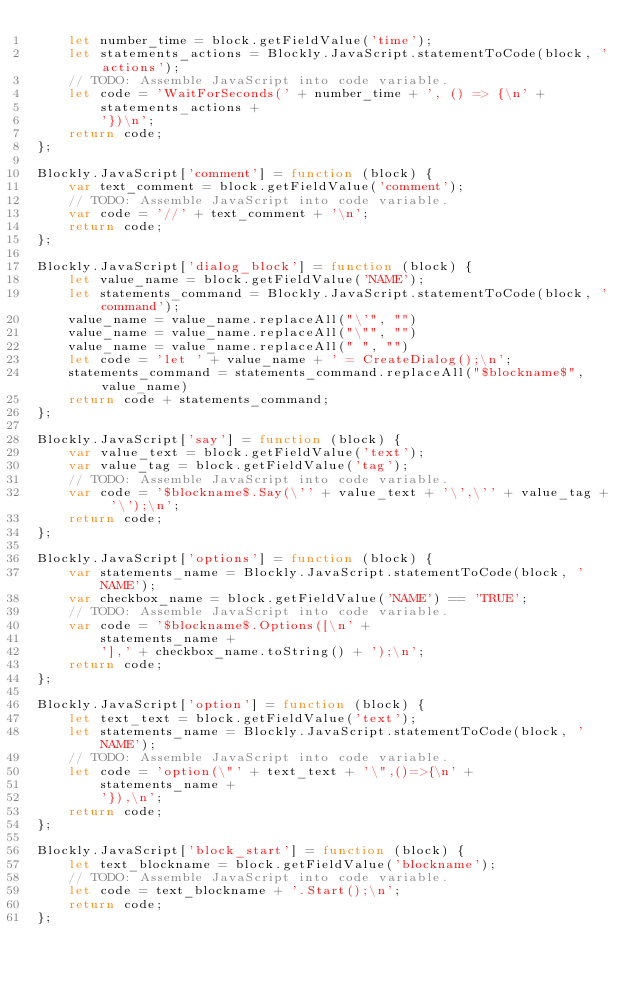Convert code to text. <code><loc_0><loc_0><loc_500><loc_500><_JavaScript_>    let number_time = block.getFieldValue('time');
    let statements_actions = Blockly.JavaScript.statementToCode(block, 'actions');
    // TODO: Assemble JavaScript into code variable.
    let code = 'WaitForSeconds(' + number_time + ', () => {\n' +
        statements_actions +
        '})\n';
    return code;
};

Blockly.JavaScript['comment'] = function (block) {
    var text_comment = block.getFieldValue('comment');
    // TODO: Assemble JavaScript into code variable.
    var code = '//' + text_comment + '\n';
    return code;
};

Blockly.JavaScript['dialog_block'] = function (block) {
    let value_name = block.getFieldValue('NAME');
    let statements_command = Blockly.JavaScript.statementToCode(block, 'command');
    value_name = value_name.replaceAll("\'", "")
    value_name = value_name.replaceAll("\"", "")
    value_name = value_name.replaceAll(" ", "")
    let code = 'let ' + value_name + ' = CreateDialog();\n';
    statements_command = statements_command.replaceAll("$blockname$", value_name)
    return code + statements_command;
};

Blockly.JavaScript['say'] = function (block) {
    var value_text = block.getFieldValue('text');
    var value_tag = block.getFieldValue('tag');
    // TODO: Assemble JavaScript into code variable.
    var code = '$blockname$.Say(\'' + value_text + '\',\'' + value_tag + '\');\n';
    return code;
};

Blockly.JavaScript['options'] = function (block) {
    var statements_name = Blockly.JavaScript.statementToCode(block, 'NAME');
    var checkbox_name = block.getFieldValue('NAME') == 'TRUE';
    // TODO: Assemble JavaScript into code variable.
    var code = '$blockname$.Options([\n' +
        statements_name +
        '],' + checkbox_name.toString() + ');\n';
    return code;
};

Blockly.JavaScript['option'] = function (block) {
    let text_text = block.getFieldValue('text');
    let statements_name = Blockly.JavaScript.statementToCode(block, 'NAME');
    // TODO: Assemble JavaScript into code variable.
    let code = 'option(\"' + text_text + '\",()=>{\n' +
        statements_name +
        '}),\n';
    return code;
};

Blockly.JavaScript['block_start'] = function (block) {
    let text_blockname = block.getFieldValue('blockname');
    // TODO: Assemble JavaScript into code variable.
    let code = text_blockname + '.Start();\n';
    return code;
};</code> 